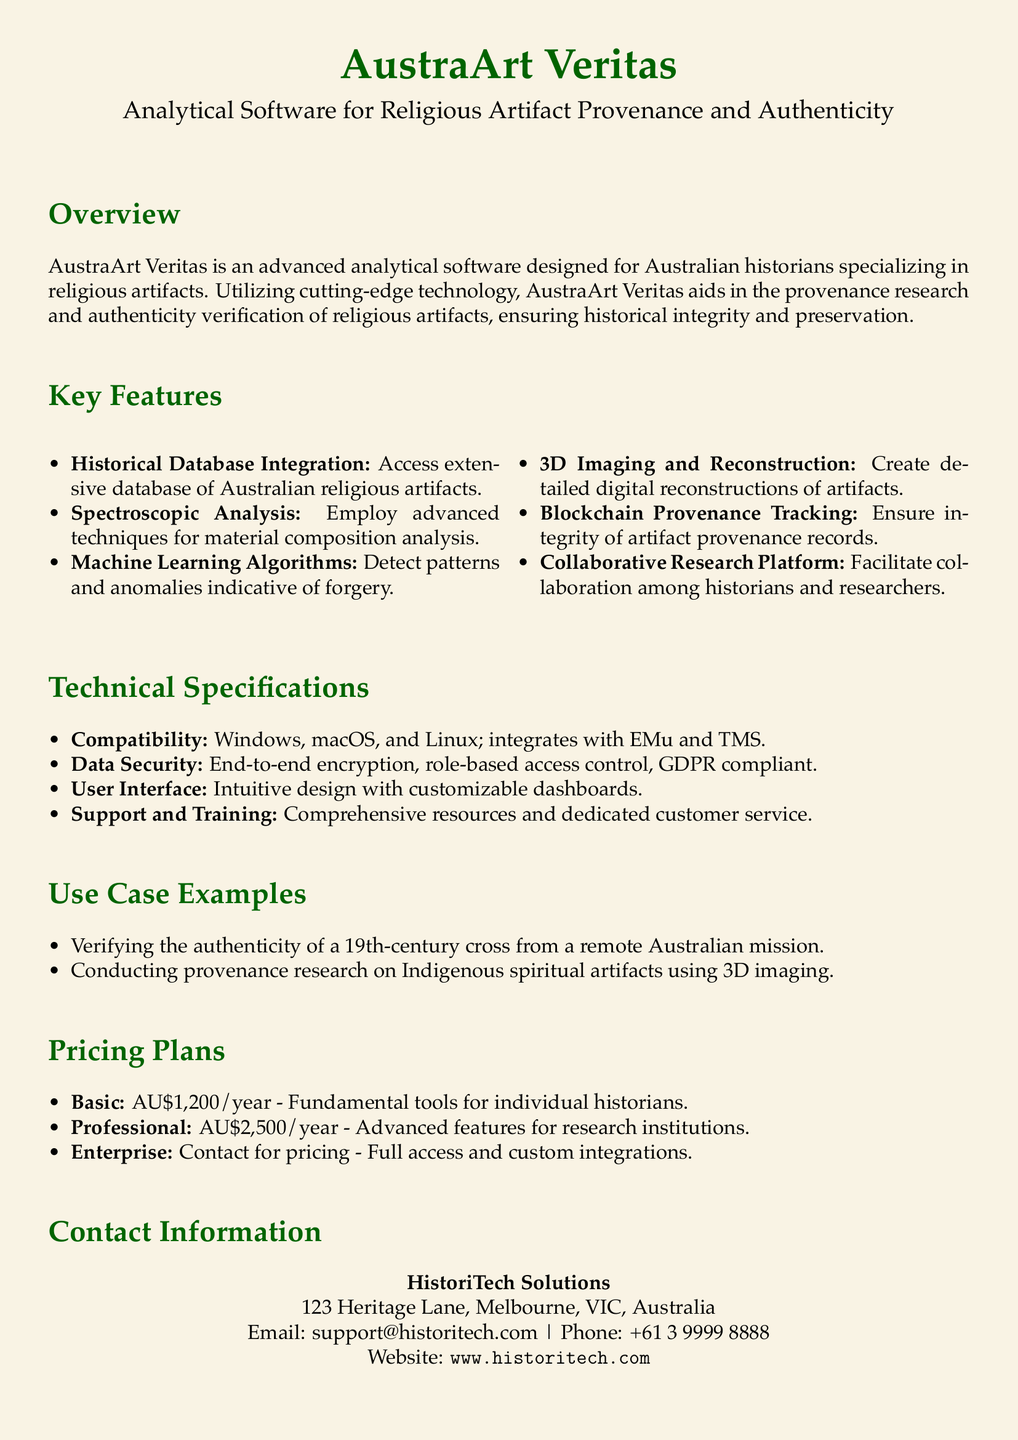What is the name of the software? The software is titled "AustraArt Veritas."
Answer: AustraArt Veritas What is the main purpose of AustraArt Veritas? The software is designed for provenance research and authenticity verification of religious artifacts.
Answer: Provenance research and authenticity verification What is the price of the Basic plan? The document specifies that the Basic plan costs AU$1,200 per year.
Answer: AU$1,200/year Which operating systems are compatible with AustraArt Veritas? The compatibility information states that it works with Windows, macOS, and Linux.
Answer: Windows, macOS, and Linux What key feature allows for detecting forgery? The software uses machine learning algorithms to detect patterns and anomalies indicative of forgery.
Answer: Machine Learning Algorithms How does AustraArt Veritas ensure data security? The document mentions end-to-end encryption and role-based access control as key security features.
Answer: End-to-end encryption, role-based access control What type of research platform does the software offer? The software includes a collaborative research platform for historians and researchers.
Answer: Collaborative Research Platform Where is HistoriTech Solutions located? The contact information states that they are located at 123 Heritage Lane, Melbourne, VIC, Australia.
Answer: 123 Heritage Lane, Melbourne, VIC, Australia What technique is mentioned for analyzing material composition? The software employs spectroscopic analysis for material composition.
Answer: Spectroscopic Analysis 